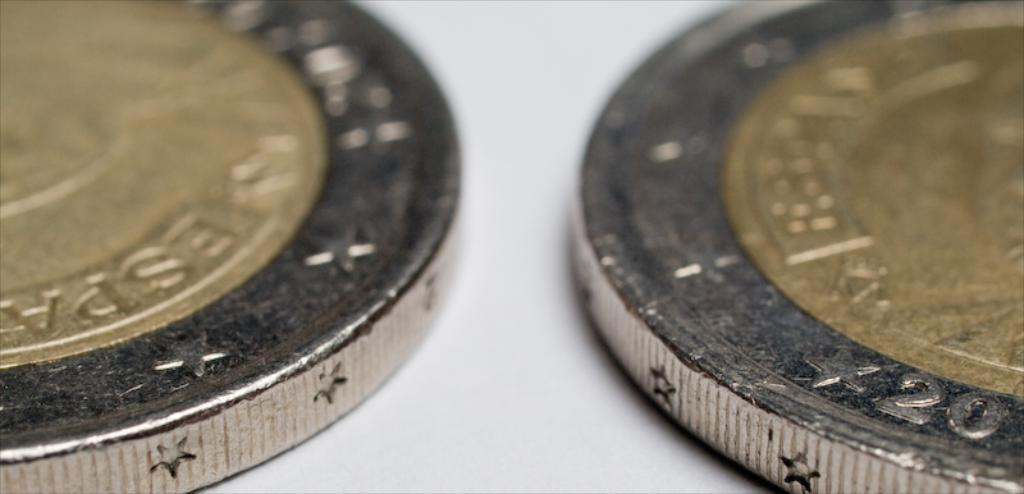<image>
Provide a brief description of the given image. The coin on the right with the numbers 20 in silver. 